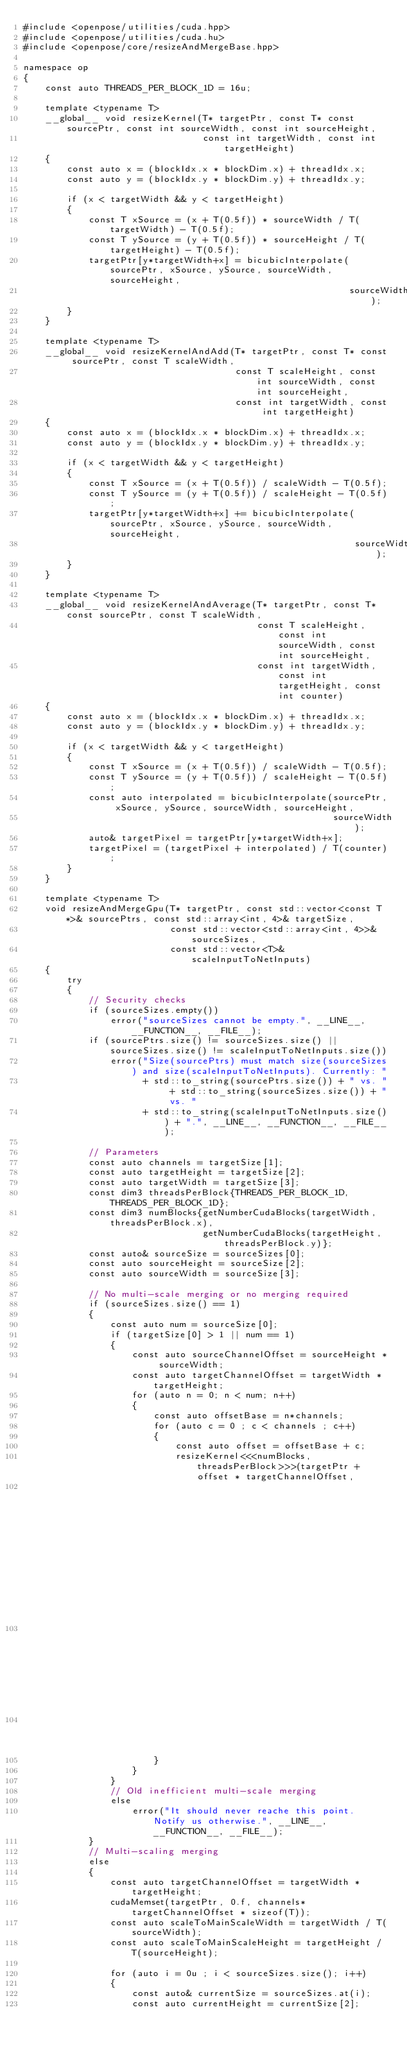<code> <loc_0><loc_0><loc_500><loc_500><_Cuda_>#include <openpose/utilities/cuda.hpp>
#include <openpose/utilities/cuda.hu>
#include <openpose/core/resizeAndMergeBase.hpp>

namespace op
{
    const auto THREADS_PER_BLOCK_1D = 16u;

    template <typename T>
    __global__ void resizeKernel(T* targetPtr, const T* const sourcePtr, const int sourceWidth, const int sourceHeight,
                                 const int targetWidth, const int targetHeight)
    {
        const auto x = (blockIdx.x * blockDim.x) + threadIdx.x;
        const auto y = (blockIdx.y * blockDim.y) + threadIdx.y;

        if (x < targetWidth && y < targetHeight)
        {
            const T xSource = (x + T(0.5f)) * sourceWidth / T(targetWidth) - T(0.5f);
            const T ySource = (y + T(0.5f)) * sourceHeight / T(targetHeight) - T(0.5f);
            targetPtr[y*targetWidth+x] = bicubicInterpolate(sourcePtr, xSource, ySource, sourceWidth, sourceHeight,
                                                            sourceWidth);
        }
    }

    template <typename T>
    __global__ void resizeKernelAndAdd(T* targetPtr, const T* const sourcePtr, const T scaleWidth,
                                       const T scaleHeight, const int sourceWidth, const int sourceHeight,
                                       const int targetWidth, const int targetHeight)
    {
        const auto x = (blockIdx.x * blockDim.x) + threadIdx.x;
        const auto y = (blockIdx.y * blockDim.y) + threadIdx.y;

        if (x < targetWidth && y < targetHeight)
        {
            const T xSource = (x + T(0.5f)) / scaleWidth - T(0.5f);
            const T ySource = (y + T(0.5f)) / scaleHeight - T(0.5f);
            targetPtr[y*targetWidth+x] += bicubicInterpolate(sourcePtr, xSource, ySource, sourceWidth, sourceHeight,
                                                             sourceWidth);
        }
    }

    template <typename T>
    __global__ void resizeKernelAndAverage(T* targetPtr, const T* const sourcePtr, const T scaleWidth,
                                           const T scaleHeight, const int sourceWidth, const int sourceHeight,
                                           const int targetWidth, const int targetHeight, const int counter)
    {
        const auto x = (blockIdx.x * blockDim.x) + threadIdx.x;
        const auto y = (blockIdx.y * blockDim.y) + threadIdx.y;

        if (x < targetWidth && y < targetHeight)
        {
            const T xSource = (x + T(0.5f)) / scaleWidth - T(0.5f);
            const T ySource = (y + T(0.5f)) / scaleHeight - T(0.5f);
            const auto interpolated = bicubicInterpolate(sourcePtr, xSource, ySource, sourceWidth, sourceHeight,
                                                         sourceWidth);
            auto& targetPixel = targetPtr[y*targetWidth+x];
            targetPixel = (targetPixel + interpolated) / T(counter);
        }
    }

    template <typename T>
    void resizeAndMergeGpu(T* targetPtr, const std::vector<const T*>& sourcePtrs, const std::array<int, 4>& targetSize,
                           const std::vector<std::array<int, 4>>& sourceSizes,
                           const std::vector<T>& scaleInputToNetInputs)
    {
        try
        {
            // Security checks
            if (sourceSizes.empty())
                error("sourceSizes cannot be empty.", __LINE__, __FUNCTION__, __FILE__);
            if (sourcePtrs.size() != sourceSizes.size() || sourceSizes.size() != scaleInputToNetInputs.size())
                error("Size(sourcePtrs) must match size(sourceSizes) and size(scaleInputToNetInputs). Currently: "
                      + std::to_string(sourcePtrs.size()) + " vs. " + std::to_string(sourceSizes.size()) + " vs. "
                      + std::to_string(scaleInputToNetInputs.size()) + ".", __LINE__, __FUNCTION__, __FILE__);

            // Parameters
            const auto channels = targetSize[1];
            const auto targetHeight = targetSize[2];
            const auto targetWidth = targetSize[3];
            const dim3 threadsPerBlock{THREADS_PER_BLOCK_1D, THREADS_PER_BLOCK_1D};
            const dim3 numBlocks{getNumberCudaBlocks(targetWidth, threadsPerBlock.x),
                                 getNumberCudaBlocks(targetHeight, threadsPerBlock.y)};
            const auto& sourceSize = sourceSizes[0];
            const auto sourceHeight = sourceSize[2];
            const auto sourceWidth = sourceSize[3];

            // No multi-scale merging or no merging required
            if (sourceSizes.size() == 1)
            {
                const auto num = sourceSize[0];
                if (targetSize[0] > 1 || num == 1)
                {
                    const auto sourceChannelOffset = sourceHeight * sourceWidth;
                    const auto targetChannelOffset = targetWidth * targetHeight;
                    for (auto n = 0; n < num; n++)
                    {
                        const auto offsetBase = n*channels;
                        for (auto c = 0 ; c < channels ; c++)
                        {
                            const auto offset = offsetBase + c;
                            resizeKernel<<<numBlocks, threadsPerBlock>>>(targetPtr + offset * targetChannelOffset,
                                                                         sourcePtrs.at(0) + offset * sourceChannelOffset,
                                                                         sourceWidth, sourceHeight, targetWidth,
                                                                         targetHeight);
                        }
                    }
                }
                // Old inefficient multi-scale merging
                else
                    error("It should never reache this point. Notify us otherwise.", __LINE__, __FUNCTION__, __FILE__);
            }
            // Multi-scaling merging
            else
            {
                const auto targetChannelOffset = targetWidth * targetHeight;
                cudaMemset(targetPtr, 0.f, channels*targetChannelOffset * sizeof(T));
                const auto scaleToMainScaleWidth = targetWidth / T(sourceWidth);
                const auto scaleToMainScaleHeight = targetHeight / T(sourceHeight);

                for (auto i = 0u ; i < sourceSizes.size(); i++)
                {
                    const auto& currentSize = sourceSizes.at(i);
                    const auto currentHeight = currentSize[2];</code> 